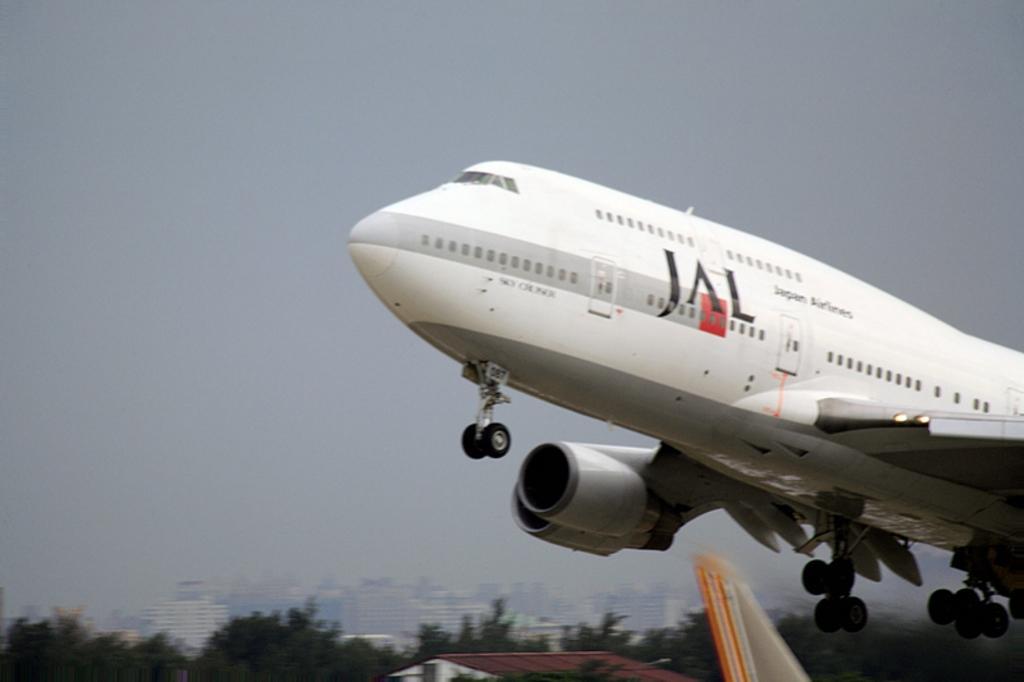Can you describe this image briefly? In this picture, we can see a flight, buildings, trees, and the sky. 